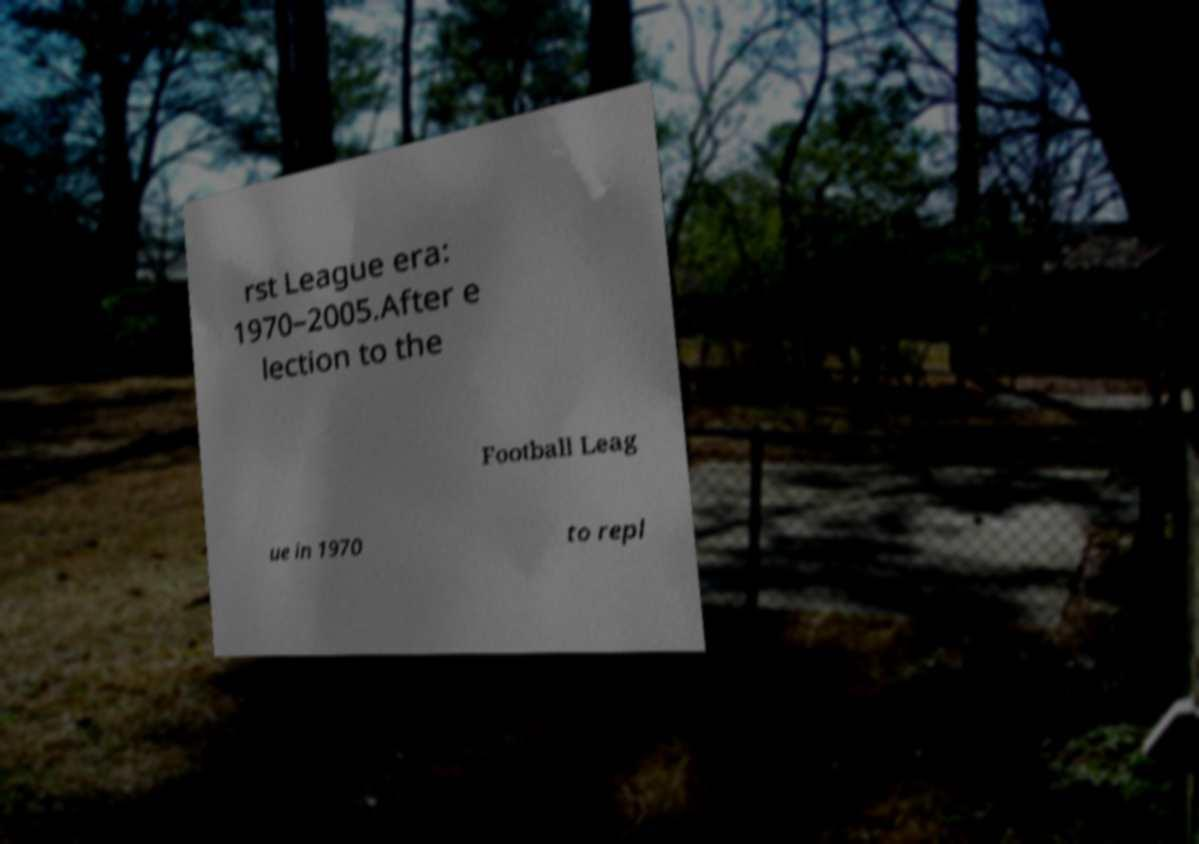Please identify and transcribe the text found in this image. rst League era: 1970–2005.After e lection to the Football Leag ue in 1970 to repl 